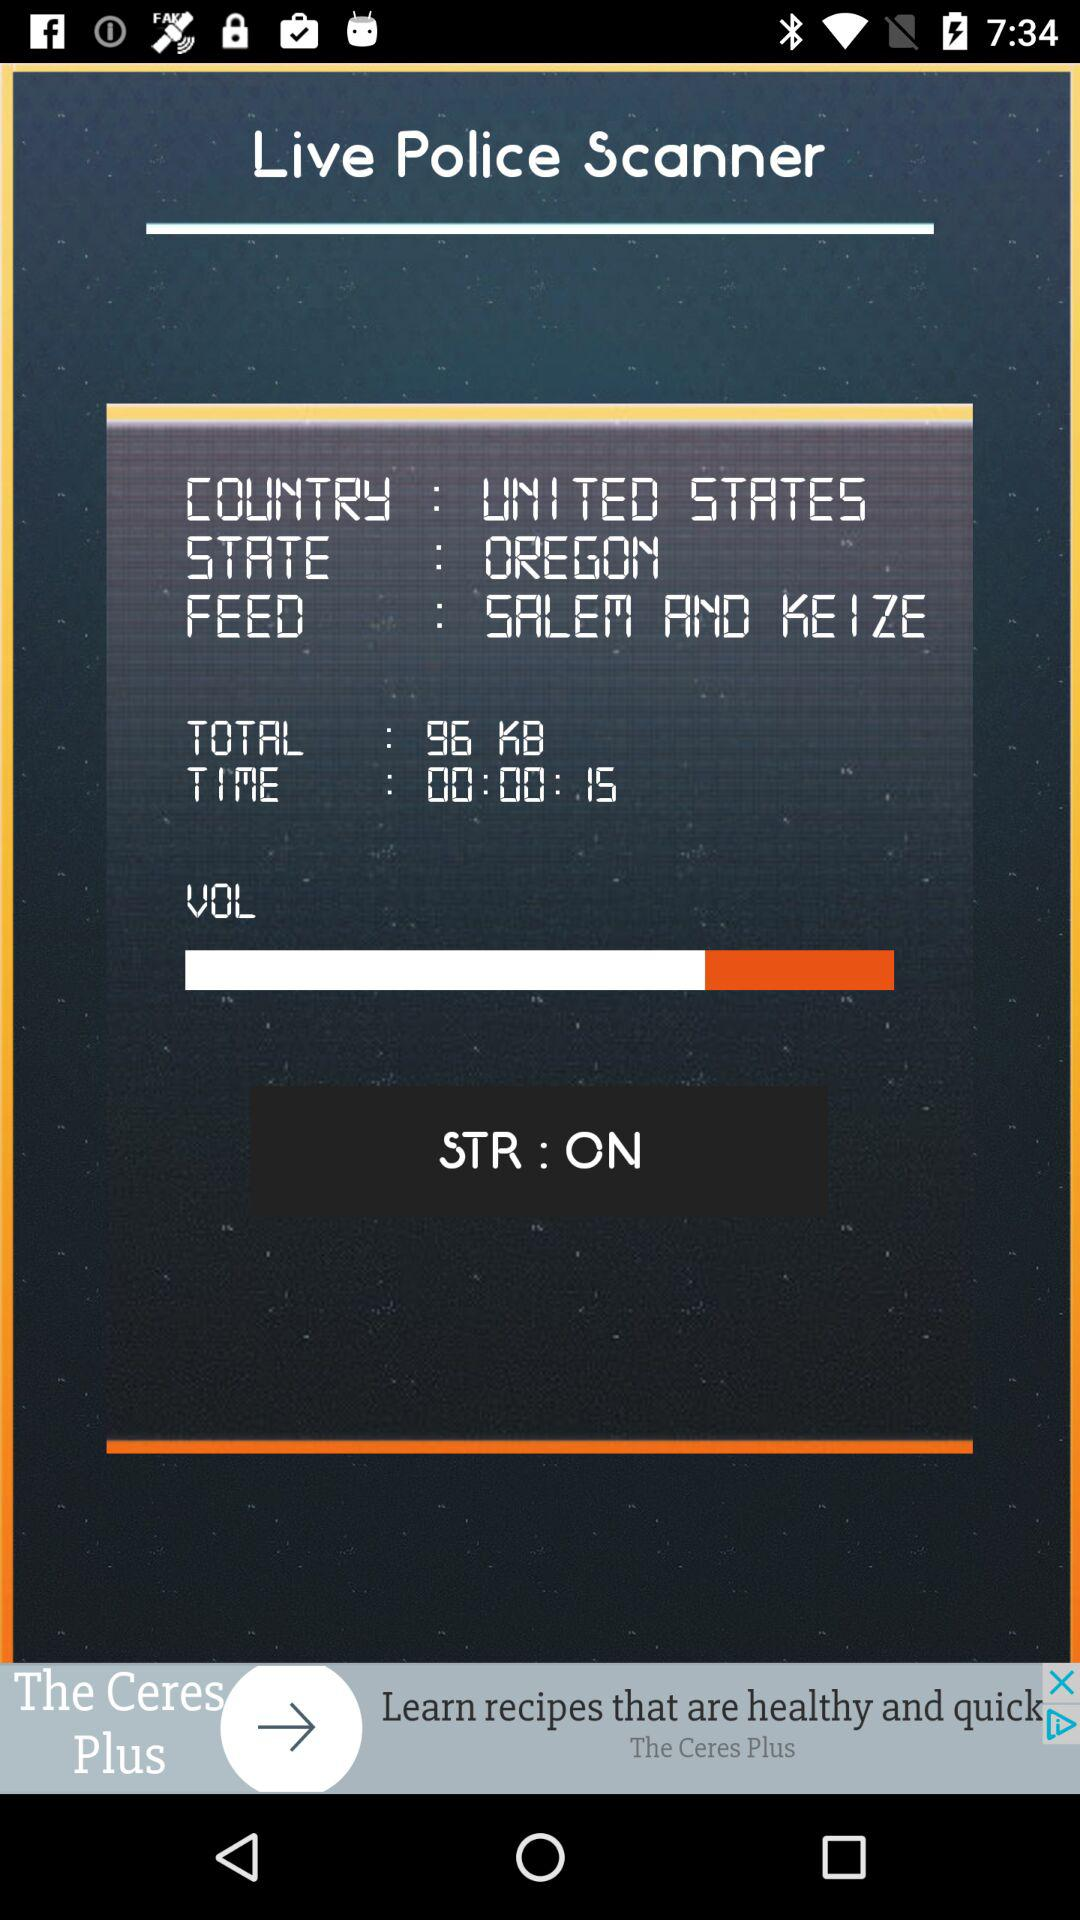What is the name of the country? The name of the country is the United States. 